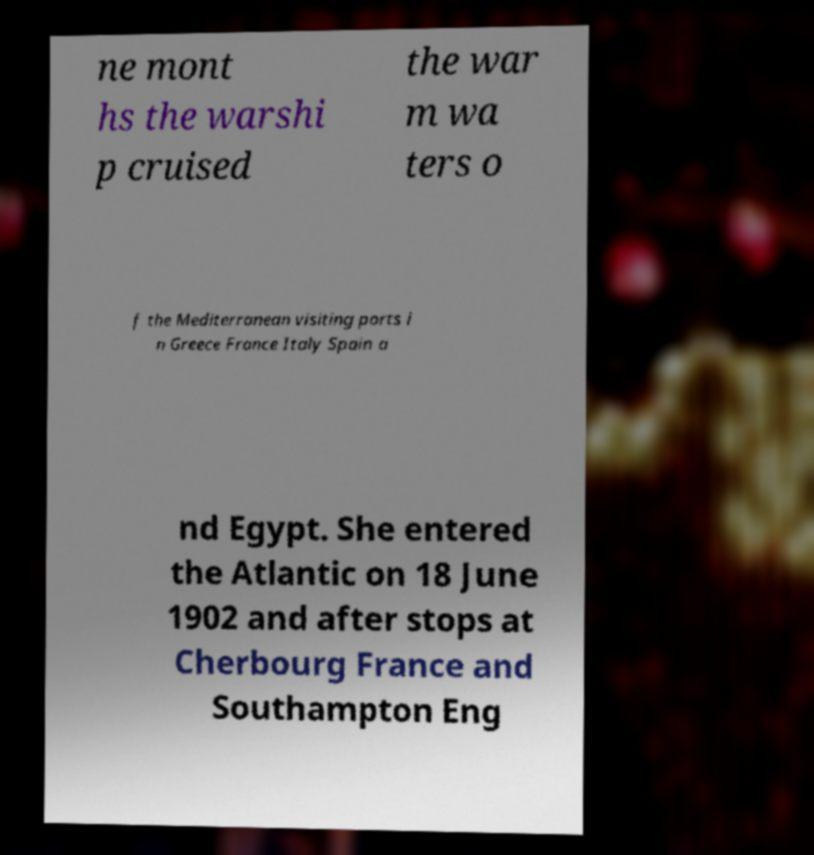Could you assist in decoding the text presented in this image and type it out clearly? ne mont hs the warshi p cruised the war m wa ters o f the Mediterranean visiting ports i n Greece France Italy Spain a nd Egypt. She entered the Atlantic on 18 June 1902 and after stops at Cherbourg France and Southampton Eng 